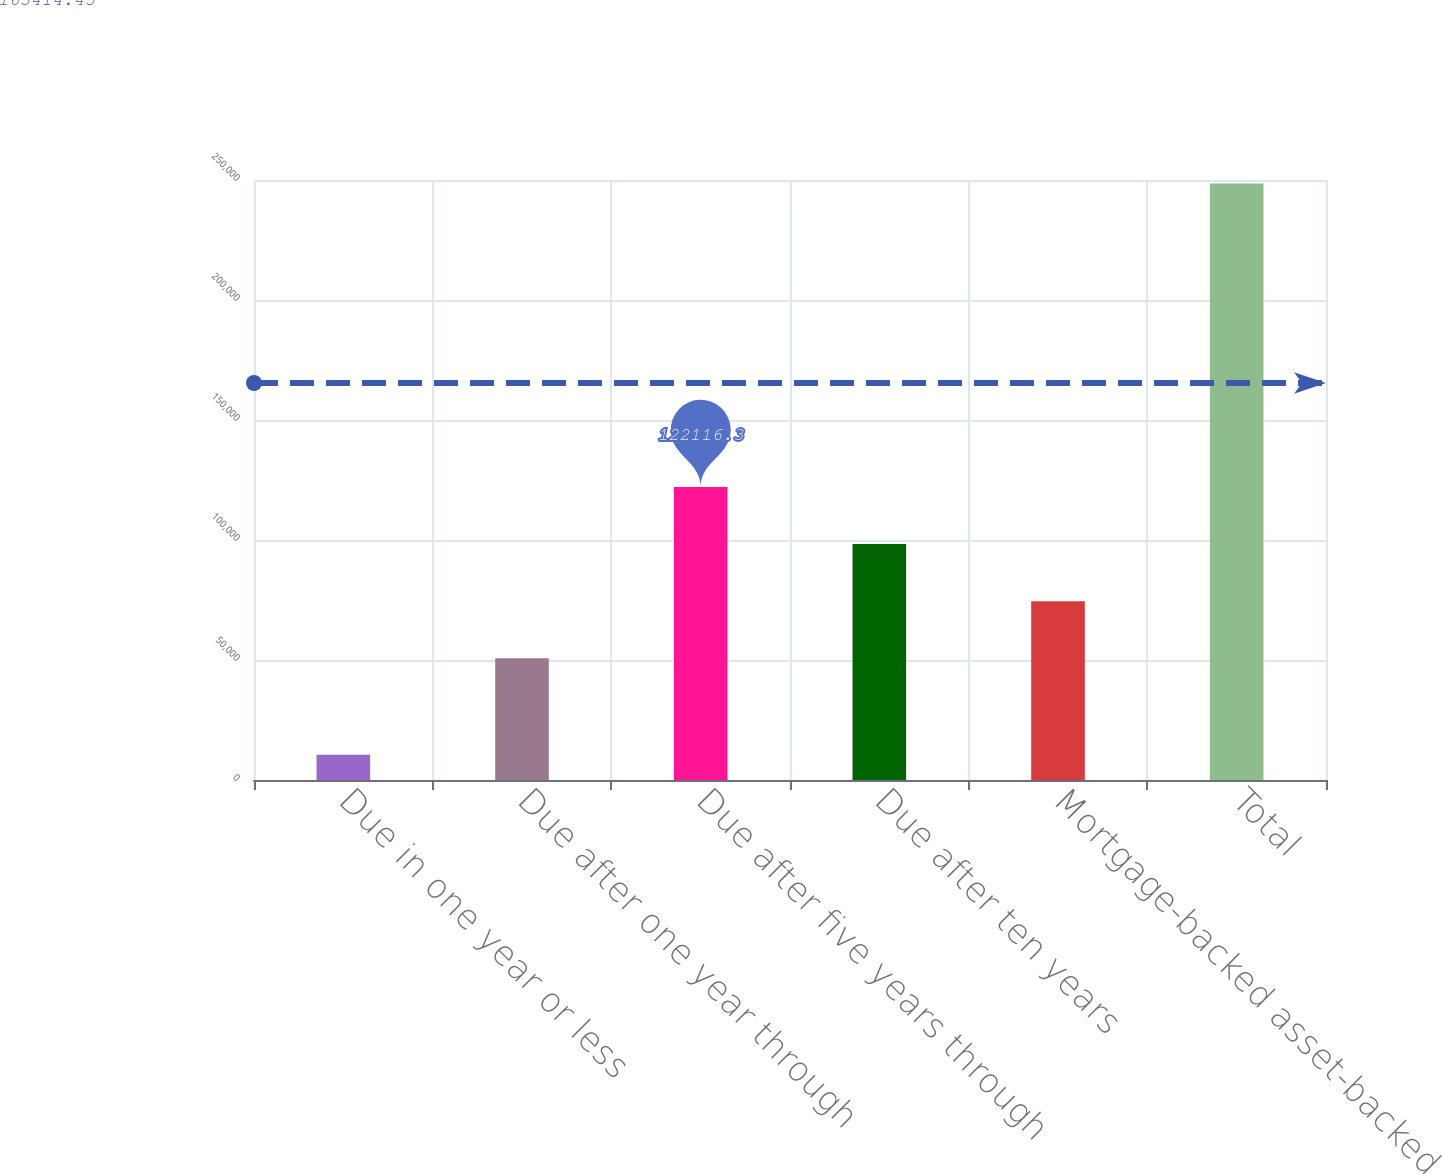<chart> <loc_0><loc_0><loc_500><loc_500><bar_chart><fcel>Due in one year or less<fcel>Due after one year through<fcel>Due after five years through<fcel>Due after ten years<fcel>Mortgage-backed asset-backed<fcel>Total<nl><fcel>10470<fcel>50698<fcel>122116<fcel>98310.2<fcel>74504.1<fcel>248531<nl></chart> 